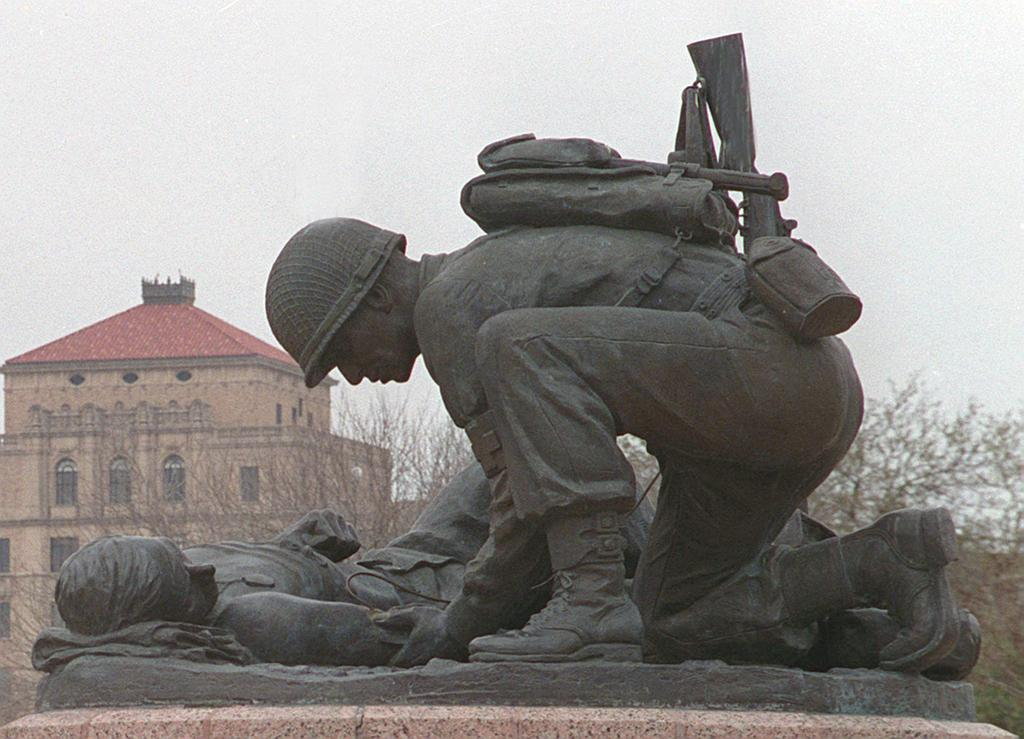What can be seen at the front of the image? There are statues in the front of the image. What is visible in the background of the image? There are trees and a house in the background of the image. How would you describe the sky in the image? The sky is cloudy in the image. Can you see a pig made of wax in the image? There is no pig made of wax present in the image. How many statues are pushing the house in the image? There are no statues pushing the house in the image; the statues are stationary, and the house is in the background. 